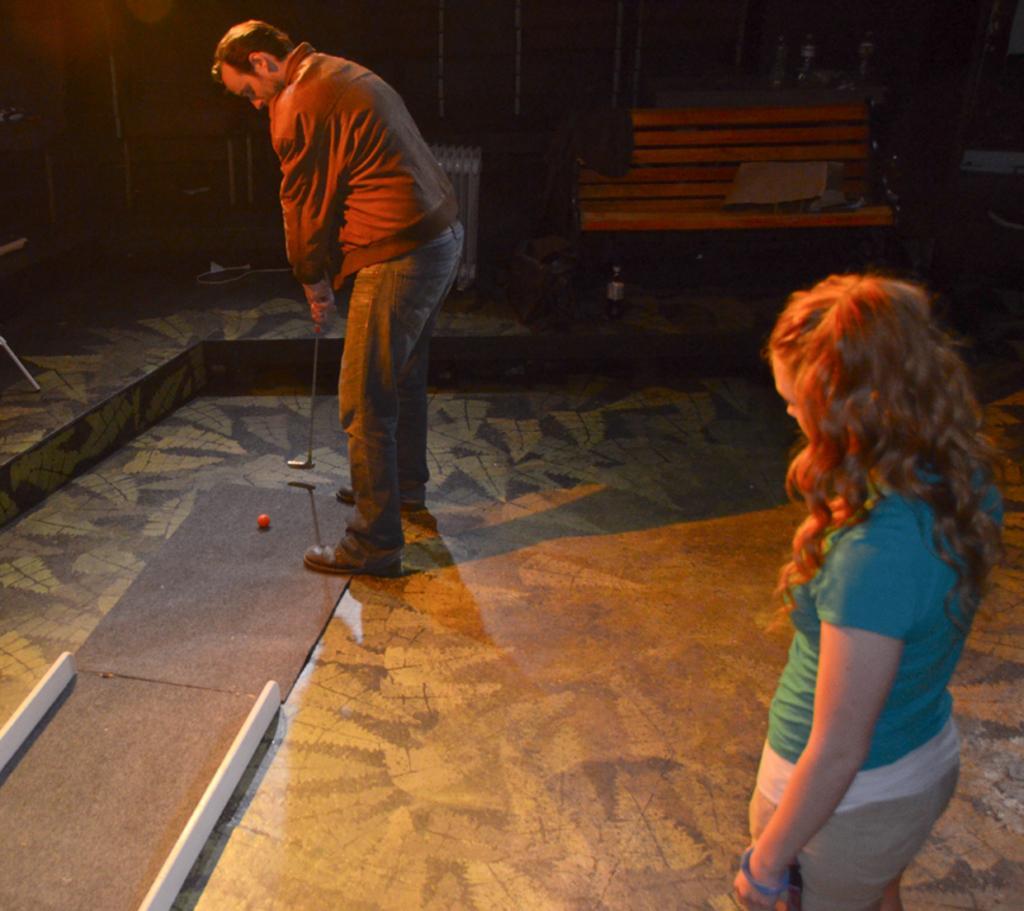Please provide a concise description of this image. In this picture there are two people standing, among them there's a man holding a stick and we can see ball and floor. In the background of the image we can see bench, bottles and objects. 